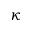Convert formula to latex. <formula><loc_0><loc_0><loc_500><loc_500>\kappa</formula> 